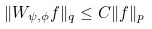Convert formula to latex. <formula><loc_0><loc_0><loc_500><loc_500>\| W _ { \psi , \phi } f \| _ { q } \leq C \| f \| _ { p }</formula> 